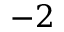<formula> <loc_0><loc_0><loc_500><loc_500>- 2</formula> 